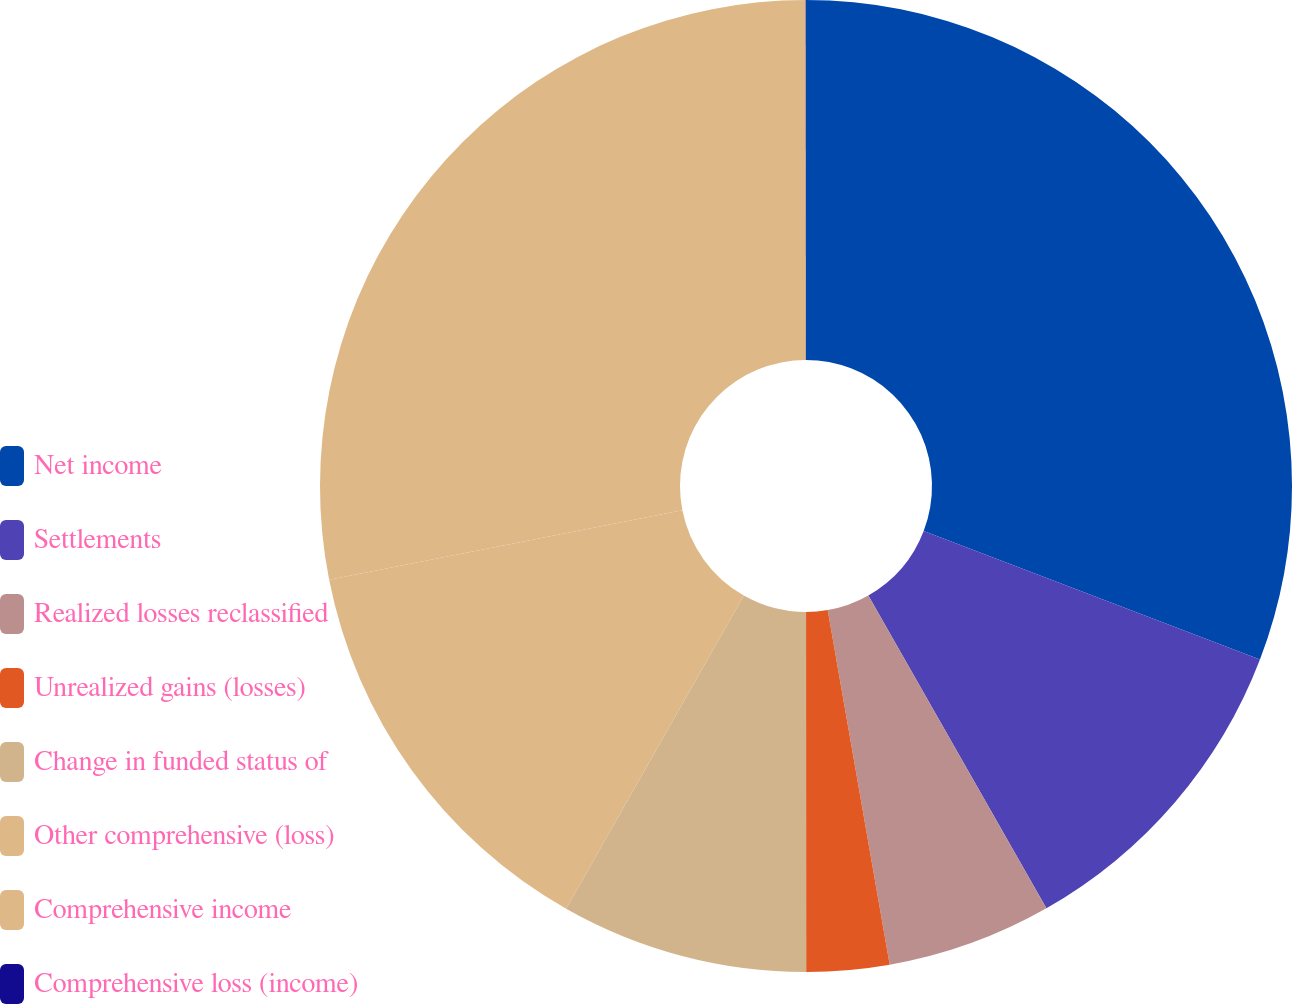Convert chart to OTSL. <chart><loc_0><loc_0><loc_500><loc_500><pie_chart><fcel>Net income<fcel>Settlements<fcel>Realized losses reclassified<fcel>Unrealized gains (losses)<fcel>Change in funded status of<fcel>Other comprehensive (loss)<fcel>Comprehensive income<fcel>Comprehensive loss (income)<nl><fcel>30.81%<fcel>10.95%<fcel>5.48%<fcel>2.75%<fcel>8.22%<fcel>13.69%<fcel>28.08%<fcel>0.01%<nl></chart> 